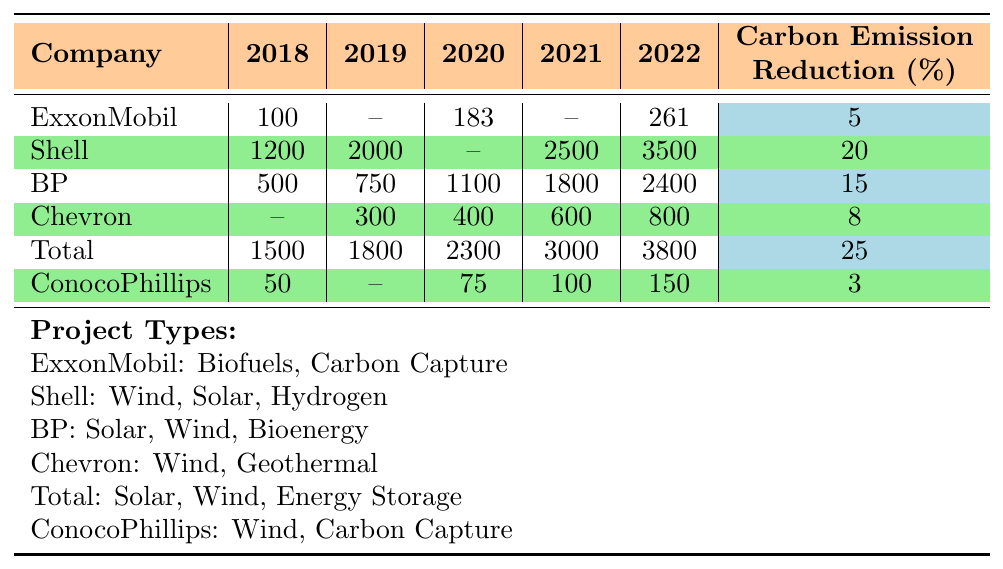What was the total investment made by Shell from 2018 to 2022? Shell's investments for the years are 1200 (2018), 2000 (2019), 2500 (2021), and 3500 (2022). Summing these: 1200 + 2000 + 2500 + 3500 = 9200.
Answer: 9200 Which company had the highest investment in renewable energy in 2022? In 2022, the investments for each company are: ExxonMobil: 261, Shell: 3500, BP: 2400, Chevron: 800, Total: 3800, ConocoPhillips: 150. The highest is Shell at 3500.
Answer: Shell How much did BP invest in renewable energy in the year 2020? BP's investment in 2020 is listed as 1100.
Answer: 1100 Which company had the lowest carbon emission reduction percentage and what was that percentage? The carbon emission reduction percentages are: ExxonMobil: 5%, Shell: 20%, BP: 15%, Chevron: 8%, Total: 25%, ConocoPhillips: 3%. The lowest is ConocoPhillips at 3%.
Answer: 3% What was the difference in investment between Total in 2022 and ExxonMobil in the same year? Total's investment in 2022 is 3800 and ExxonMobil's is 261. The difference is 3800 - 261 = 3539.
Answer: 3539 What percentage of the total investment in 2021 was made by BP? The total investments in 2021 are Shell: 2500, BP: 1800, Chevron: 600, Total: 3000, ConocoPhillips: 100. The total is 2500 + 1800 + 600 + 3000 + 100 = 7990. BP's investment is 1800, so the percentage is (1800/7990) * 100 ≈ 22.5%.
Answer: 22.5% Did Chevron invest in renewable energy in 2018? Chevron's investments show no value listed for 2018, indicating that they did not invest in that year.
Answer: No How does Total's total investment from 2018 to 2022 compare to ExxonMobil's investment over the same period? Total's investments are: 1500 (2018), 1800 (2019), 2300 (2020), 3000 (2021), 3800 (2022) = 1500 + 1800 + 2300 + 3000 + 3800 = 12200. ExxonMobil's investments are 100 (2018), 183 (2020), and 261 (2022) = 100 + 183 + 261 = 544. Comparing totals: 12200 - 544 = 11656 more in favor of Total.
Answer: Total invested 11656 more than ExxonMobil How many different types of renewable energy projects does Shell invest in? Shell invests in three project types: Wind, Solar, and Hydrogen. Counting these gives us three.
Answer: 3 What is the average carbon emission reduction percentage of the companies listed? The reduction percentages are: 5, 20, 15, 8, 25, and 3. The average is (5 + 20 + 15 + 8 + 25 + 3) / 6 = 76 / 6 = 12.67.
Answer: 12.67 Which company’s investment pattern shows a steady increase from 2018 to 2022? Examining the investment patterns, Shell and Total show a consistent increase each year from 2018 to 2022.
Answer: Shell and Total 